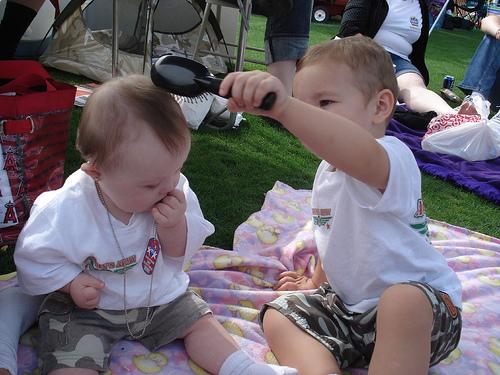Do they look like twins?
Concise answer only. No. What is the kid doing to the other kid?
Write a very short answer. Brushing hair. How many children are there?
Be succinct. 2. 